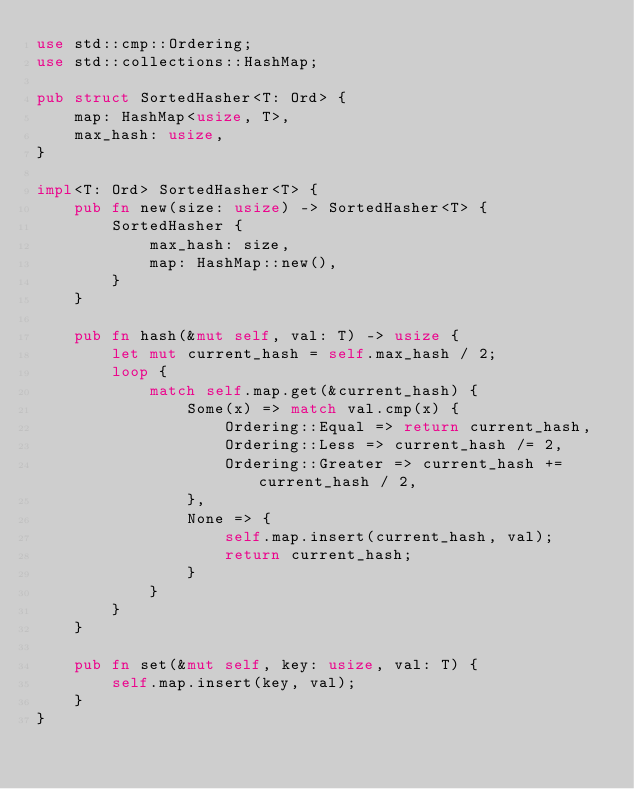Convert code to text. <code><loc_0><loc_0><loc_500><loc_500><_Rust_>use std::cmp::Ordering;
use std::collections::HashMap;

pub struct SortedHasher<T: Ord> {
    map: HashMap<usize, T>,
    max_hash: usize,
}

impl<T: Ord> SortedHasher<T> {
    pub fn new(size: usize) -> SortedHasher<T> {
        SortedHasher {
            max_hash: size,
            map: HashMap::new(),
        }
    }

    pub fn hash(&mut self, val: T) -> usize {
        let mut current_hash = self.max_hash / 2;
        loop {
            match self.map.get(&current_hash) {
                Some(x) => match val.cmp(x) {
                    Ordering::Equal => return current_hash,
                    Ordering::Less => current_hash /= 2,
                    Ordering::Greater => current_hash += current_hash / 2,
                },
                None => {
                    self.map.insert(current_hash, val);
                    return current_hash;
                }
            }
        }
    }

    pub fn set(&mut self, key: usize, val: T) {
        self.map.insert(key, val);
    }
}
</code> 